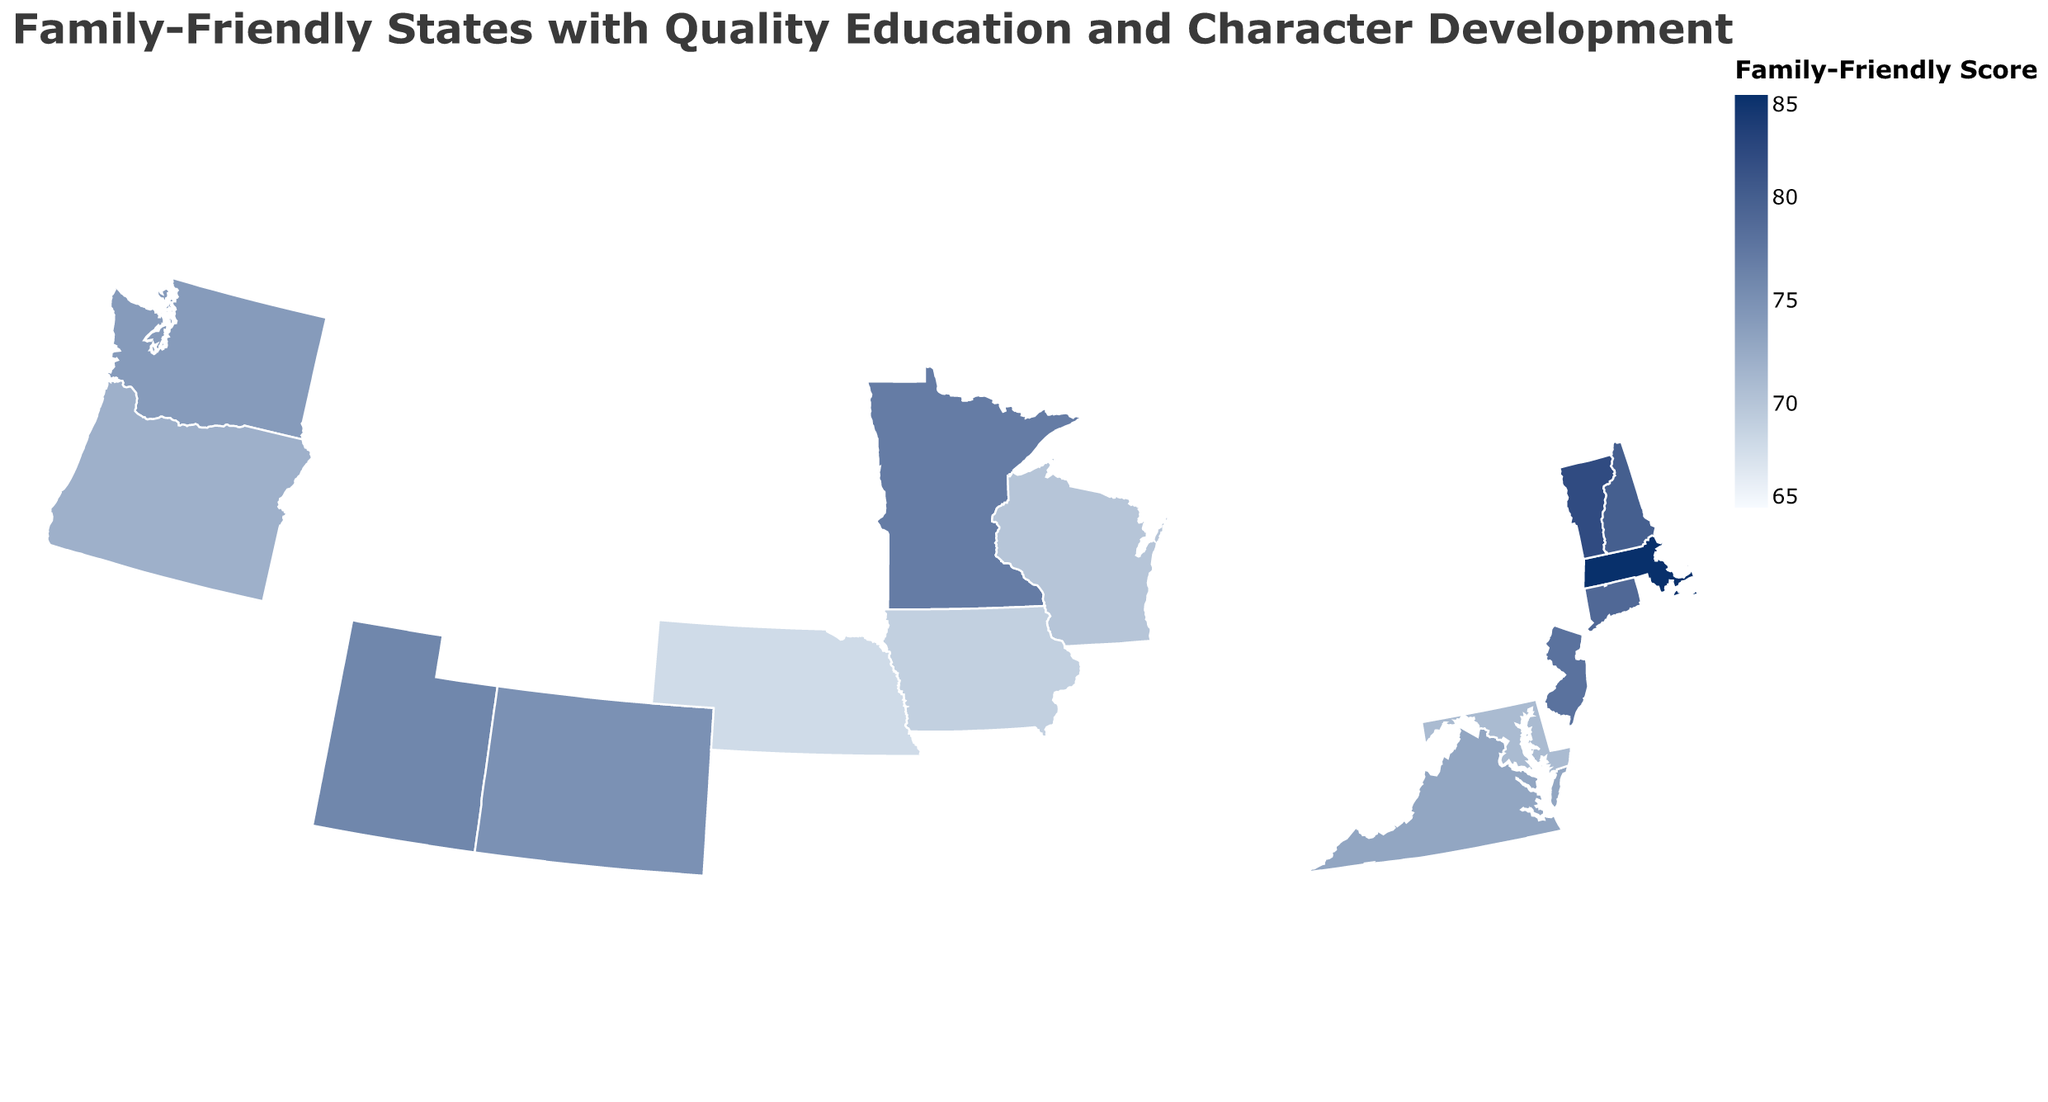How many states have a family-friendly score greater than or equal to 80? Count the number of states with a family-friendly score of 80 or more on the color scale. The states are Massachusetts, Vermont, and New Hampshire.
Answer: 3 Which state has the highest crime rate? Identify the state with the darkest color in the range of crime rate values in the tooltip. Maryland has the highest crime rate of 3.8.
Answer: Maryland What is the average education quality score for the three states with the highest family-friendly scores? Identify the states with the highest family-friendly scores: Massachusetts, Vermont, and New Hampshire. Add their education quality scores (92, 89, and 88) and divide by 3 to get the average. (92 + 89 + 88) / 3 = 89.67
Answer: 89.67 Which state has the most extensive character development programs? Look at the tooltip information for each state to find the one with the highest character development programs score. Utah has the highest score of 88.
Answer: Utah Compare the family-friendly score between Utah and Virginia. Which state scores higher? Check the family-friendly scores of Utah (76) and Virginia (73) in the tooltip. Utah has a higher score than Virginia.
Answer: Utah What is the difference in crime rates between Vermont and Oregon? Identify the crime rates for Vermont (2.1) and Oregon (3.6) in the tooltip. Calculate the difference: 3.6 - 2.1 = 1.5.
Answer: 1.5 Which state has the lowest family-friendly score, and what is it? Identify the state with the lightest color in the family-friendly score color range. Nebraska has the lowest score at 68.
Answer: Nebraska How many states have education quality scores of 85 or above? Count the number of states with education quality scores of 85 or higher in the tooltips. The states are Massachusetts, Vermont, Connecticut, New Jersey, Utah, Colorado, and Maryland, totaling 7.
Answer: 7 